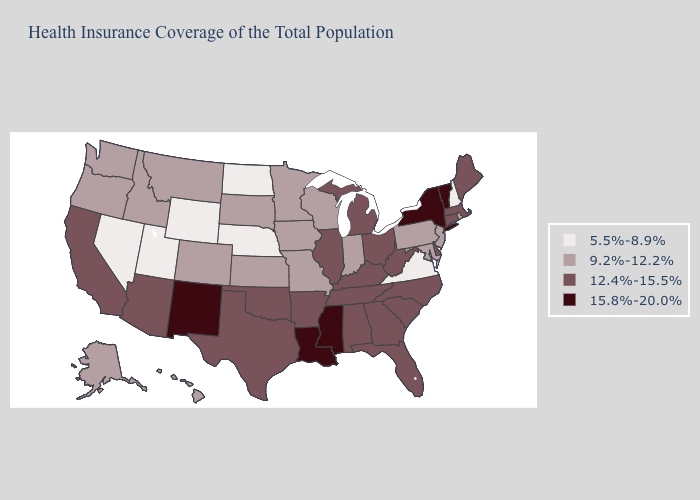What is the value of Iowa?
Short answer required. 9.2%-12.2%. Name the states that have a value in the range 5.5%-8.9%?
Give a very brief answer. Nebraska, Nevada, New Hampshire, North Dakota, Utah, Virginia, Wyoming. Does the first symbol in the legend represent the smallest category?
Short answer required. Yes. What is the highest value in states that border Idaho?
Write a very short answer. 9.2%-12.2%. Which states have the highest value in the USA?
Concise answer only. Louisiana, Mississippi, New Mexico, New York, Vermont. Does Massachusetts have the highest value in the Northeast?
Quick response, please. No. Among the states that border Kentucky , does Illinois have the highest value?
Short answer required. Yes. Name the states that have a value in the range 12.4%-15.5%?
Concise answer only. Alabama, Arizona, Arkansas, California, Connecticut, Delaware, Florida, Georgia, Illinois, Kentucky, Maine, Massachusetts, Michigan, North Carolina, Ohio, Oklahoma, South Carolina, Tennessee, Texas, West Virginia. What is the value of New York?
Keep it brief. 15.8%-20.0%. What is the highest value in the USA?
Quick response, please. 15.8%-20.0%. Among the states that border Pennsylvania , which have the lowest value?
Be succinct. Maryland, New Jersey. What is the highest value in states that border Connecticut?
Give a very brief answer. 15.8%-20.0%. Name the states that have a value in the range 9.2%-12.2%?
Quick response, please. Alaska, Colorado, Hawaii, Idaho, Indiana, Iowa, Kansas, Maryland, Minnesota, Missouri, Montana, New Jersey, Oregon, Pennsylvania, Rhode Island, South Dakota, Washington, Wisconsin. 